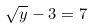<formula> <loc_0><loc_0><loc_500><loc_500>\sqrt { y } - 3 = 7</formula> 